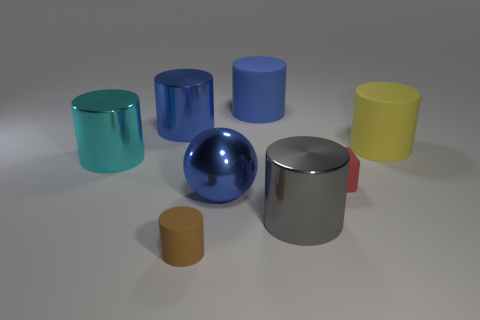How many objects are there and can you describe their shapes? There are nine objects in total, which include a sphere, several cylinders of different sizes, and cuboids also of varying dimensions. Are any of the objects translucent? Yes, the teal-colored cylinder on the left appears to be somewhat translucent, allowing light to pass through it partially. 